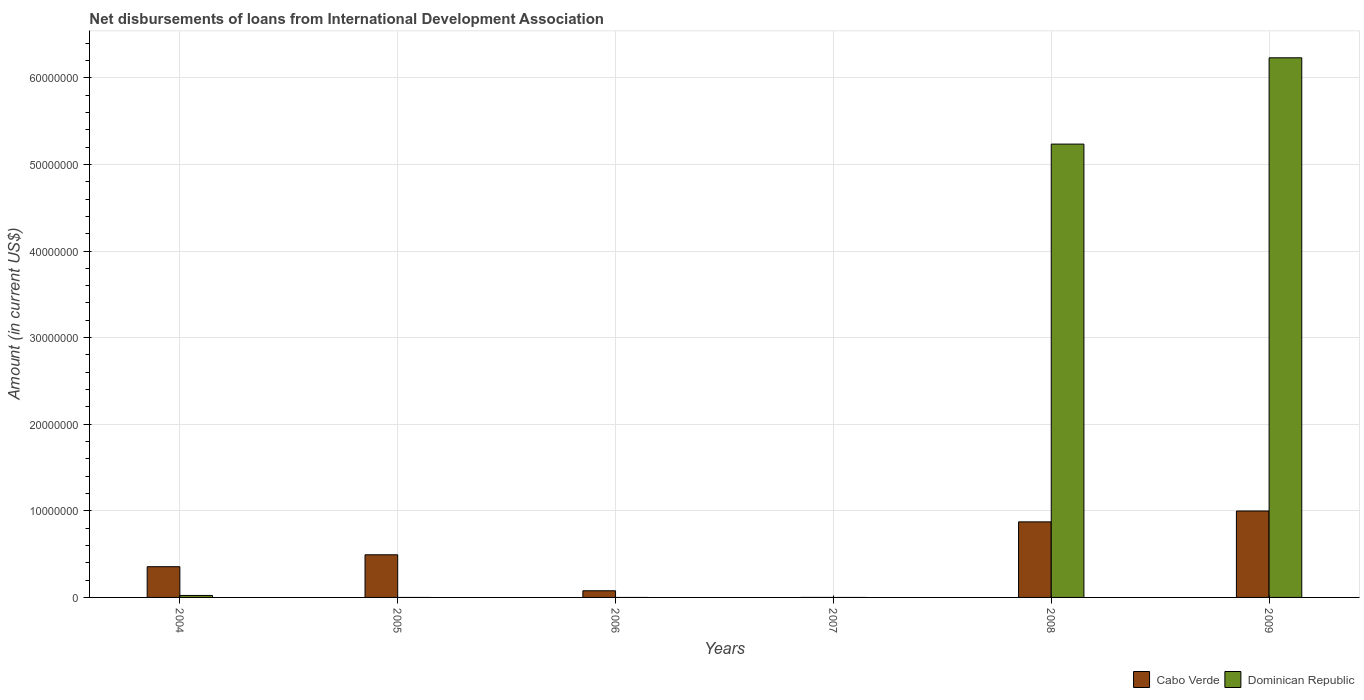How many different coloured bars are there?
Offer a terse response. 2. Are the number of bars per tick equal to the number of legend labels?
Offer a very short reply. No. Are the number of bars on each tick of the X-axis equal?
Provide a succinct answer. No. How many bars are there on the 3rd tick from the right?
Give a very brief answer. 0. What is the amount of loans disbursed in Dominican Republic in 2009?
Provide a short and direct response. 6.23e+07. Across all years, what is the maximum amount of loans disbursed in Cabo Verde?
Keep it short and to the point. 9.98e+06. Across all years, what is the minimum amount of loans disbursed in Cabo Verde?
Your answer should be compact. 0. In which year was the amount of loans disbursed in Cabo Verde maximum?
Offer a terse response. 2009. What is the total amount of loans disbursed in Dominican Republic in the graph?
Keep it short and to the point. 1.15e+08. What is the difference between the amount of loans disbursed in Cabo Verde in 2004 and that in 2005?
Give a very brief answer. -1.38e+06. What is the difference between the amount of loans disbursed in Cabo Verde in 2008 and the amount of loans disbursed in Dominican Republic in 2005?
Your answer should be compact. 8.72e+06. What is the average amount of loans disbursed in Dominican Republic per year?
Provide a short and direct response. 1.91e+07. In the year 2008, what is the difference between the amount of loans disbursed in Dominican Republic and amount of loans disbursed in Cabo Verde?
Give a very brief answer. 4.36e+07. In how many years, is the amount of loans disbursed in Cabo Verde greater than 16000000 US$?
Ensure brevity in your answer.  0. What is the ratio of the amount of loans disbursed in Cabo Verde in 2004 to that in 2006?
Offer a very short reply. 4.61. What is the difference between the highest and the second highest amount of loans disbursed in Cabo Verde?
Keep it short and to the point. 1.26e+06. What is the difference between the highest and the lowest amount of loans disbursed in Dominican Republic?
Ensure brevity in your answer.  6.23e+07. Is the sum of the amount of loans disbursed in Cabo Verde in 2004 and 2008 greater than the maximum amount of loans disbursed in Dominican Republic across all years?
Your answer should be compact. No. Are all the bars in the graph horizontal?
Keep it short and to the point. No. How many years are there in the graph?
Give a very brief answer. 6. Are the values on the major ticks of Y-axis written in scientific E-notation?
Provide a succinct answer. No. Does the graph contain grids?
Make the answer very short. Yes. How many legend labels are there?
Your response must be concise. 2. What is the title of the graph?
Make the answer very short. Net disbursements of loans from International Development Association. What is the Amount (in current US$) of Cabo Verde in 2004?
Provide a short and direct response. 3.55e+06. What is the Amount (in current US$) of Dominican Republic in 2004?
Provide a succinct answer. 2.29e+05. What is the Amount (in current US$) of Cabo Verde in 2005?
Your answer should be compact. 4.92e+06. What is the Amount (in current US$) of Cabo Verde in 2006?
Your answer should be very brief. 7.69e+05. What is the Amount (in current US$) of Cabo Verde in 2007?
Offer a terse response. 0. What is the Amount (in current US$) of Dominican Republic in 2007?
Provide a short and direct response. 0. What is the Amount (in current US$) in Cabo Verde in 2008?
Ensure brevity in your answer.  8.72e+06. What is the Amount (in current US$) in Dominican Republic in 2008?
Provide a short and direct response. 5.23e+07. What is the Amount (in current US$) in Cabo Verde in 2009?
Your answer should be very brief. 9.98e+06. What is the Amount (in current US$) of Dominican Republic in 2009?
Ensure brevity in your answer.  6.23e+07. Across all years, what is the maximum Amount (in current US$) in Cabo Verde?
Your response must be concise. 9.98e+06. Across all years, what is the maximum Amount (in current US$) of Dominican Republic?
Your answer should be very brief. 6.23e+07. Across all years, what is the minimum Amount (in current US$) in Dominican Republic?
Give a very brief answer. 0. What is the total Amount (in current US$) in Cabo Verde in the graph?
Ensure brevity in your answer.  2.79e+07. What is the total Amount (in current US$) of Dominican Republic in the graph?
Make the answer very short. 1.15e+08. What is the difference between the Amount (in current US$) of Cabo Verde in 2004 and that in 2005?
Your answer should be very brief. -1.38e+06. What is the difference between the Amount (in current US$) in Cabo Verde in 2004 and that in 2006?
Provide a short and direct response. 2.78e+06. What is the difference between the Amount (in current US$) of Cabo Verde in 2004 and that in 2008?
Provide a succinct answer. -5.18e+06. What is the difference between the Amount (in current US$) of Dominican Republic in 2004 and that in 2008?
Keep it short and to the point. -5.21e+07. What is the difference between the Amount (in current US$) of Cabo Verde in 2004 and that in 2009?
Your answer should be very brief. -6.43e+06. What is the difference between the Amount (in current US$) of Dominican Republic in 2004 and that in 2009?
Give a very brief answer. -6.21e+07. What is the difference between the Amount (in current US$) of Cabo Verde in 2005 and that in 2006?
Offer a very short reply. 4.15e+06. What is the difference between the Amount (in current US$) of Cabo Verde in 2005 and that in 2008?
Offer a terse response. -3.80e+06. What is the difference between the Amount (in current US$) in Cabo Verde in 2005 and that in 2009?
Provide a succinct answer. -5.06e+06. What is the difference between the Amount (in current US$) of Cabo Verde in 2006 and that in 2008?
Your response must be concise. -7.96e+06. What is the difference between the Amount (in current US$) in Cabo Verde in 2006 and that in 2009?
Offer a terse response. -9.21e+06. What is the difference between the Amount (in current US$) in Cabo Verde in 2008 and that in 2009?
Make the answer very short. -1.26e+06. What is the difference between the Amount (in current US$) in Dominican Republic in 2008 and that in 2009?
Offer a very short reply. -9.96e+06. What is the difference between the Amount (in current US$) in Cabo Verde in 2004 and the Amount (in current US$) in Dominican Republic in 2008?
Your response must be concise. -4.88e+07. What is the difference between the Amount (in current US$) in Cabo Verde in 2004 and the Amount (in current US$) in Dominican Republic in 2009?
Offer a terse response. -5.88e+07. What is the difference between the Amount (in current US$) of Cabo Verde in 2005 and the Amount (in current US$) of Dominican Republic in 2008?
Ensure brevity in your answer.  -4.74e+07. What is the difference between the Amount (in current US$) in Cabo Verde in 2005 and the Amount (in current US$) in Dominican Republic in 2009?
Your answer should be compact. -5.74e+07. What is the difference between the Amount (in current US$) of Cabo Verde in 2006 and the Amount (in current US$) of Dominican Republic in 2008?
Offer a very short reply. -5.16e+07. What is the difference between the Amount (in current US$) of Cabo Verde in 2006 and the Amount (in current US$) of Dominican Republic in 2009?
Keep it short and to the point. -6.15e+07. What is the difference between the Amount (in current US$) in Cabo Verde in 2008 and the Amount (in current US$) in Dominican Republic in 2009?
Your response must be concise. -5.36e+07. What is the average Amount (in current US$) in Cabo Verde per year?
Give a very brief answer. 4.66e+06. What is the average Amount (in current US$) in Dominican Republic per year?
Provide a succinct answer. 1.91e+07. In the year 2004, what is the difference between the Amount (in current US$) in Cabo Verde and Amount (in current US$) in Dominican Republic?
Your answer should be compact. 3.32e+06. In the year 2008, what is the difference between the Amount (in current US$) in Cabo Verde and Amount (in current US$) in Dominican Republic?
Ensure brevity in your answer.  -4.36e+07. In the year 2009, what is the difference between the Amount (in current US$) of Cabo Verde and Amount (in current US$) of Dominican Republic?
Your response must be concise. -5.23e+07. What is the ratio of the Amount (in current US$) in Cabo Verde in 2004 to that in 2005?
Offer a very short reply. 0.72. What is the ratio of the Amount (in current US$) in Cabo Verde in 2004 to that in 2006?
Provide a succinct answer. 4.61. What is the ratio of the Amount (in current US$) in Cabo Verde in 2004 to that in 2008?
Provide a succinct answer. 0.41. What is the ratio of the Amount (in current US$) in Dominican Republic in 2004 to that in 2008?
Your answer should be compact. 0. What is the ratio of the Amount (in current US$) of Cabo Verde in 2004 to that in 2009?
Provide a short and direct response. 0.36. What is the ratio of the Amount (in current US$) in Dominican Republic in 2004 to that in 2009?
Offer a terse response. 0. What is the ratio of the Amount (in current US$) in Cabo Verde in 2005 to that in 2006?
Your answer should be compact. 6.4. What is the ratio of the Amount (in current US$) in Cabo Verde in 2005 to that in 2008?
Make the answer very short. 0.56. What is the ratio of the Amount (in current US$) in Cabo Verde in 2005 to that in 2009?
Your answer should be very brief. 0.49. What is the ratio of the Amount (in current US$) in Cabo Verde in 2006 to that in 2008?
Your response must be concise. 0.09. What is the ratio of the Amount (in current US$) in Cabo Verde in 2006 to that in 2009?
Offer a terse response. 0.08. What is the ratio of the Amount (in current US$) of Cabo Verde in 2008 to that in 2009?
Ensure brevity in your answer.  0.87. What is the ratio of the Amount (in current US$) in Dominican Republic in 2008 to that in 2009?
Offer a very short reply. 0.84. What is the difference between the highest and the second highest Amount (in current US$) of Cabo Verde?
Keep it short and to the point. 1.26e+06. What is the difference between the highest and the second highest Amount (in current US$) in Dominican Republic?
Your answer should be compact. 9.96e+06. What is the difference between the highest and the lowest Amount (in current US$) of Cabo Verde?
Your answer should be compact. 9.98e+06. What is the difference between the highest and the lowest Amount (in current US$) in Dominican Republic?
Ensure brevity in your answer.  6.23e+07. 